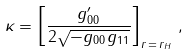Convert formula to latex. <formula><loc_0><loc_0><loc_500><loc_500>\kappa = \left [ \frac { g _ { 0 0 } ^ { \prime } } { 2 \sqrt { - g _ { 0 0 } g _ { 1 1 } } } \right ] _ { r \, = \, r _ { H } } \, ,</formula> 